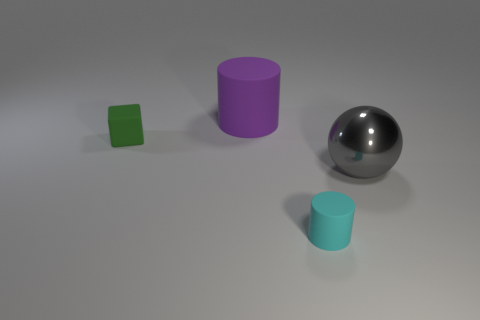There is a rubber cylinder to the right of the big purple matte cylinder behind the tiny green block; what size is it? The cylinder to the right of the big purple cylinder, which is behind the tiny green block, is of a medium size compared to the objects surrounding it. Despite its smaller size relative to the large cylinder, it is not small enough to be considered tiny like the green block. 